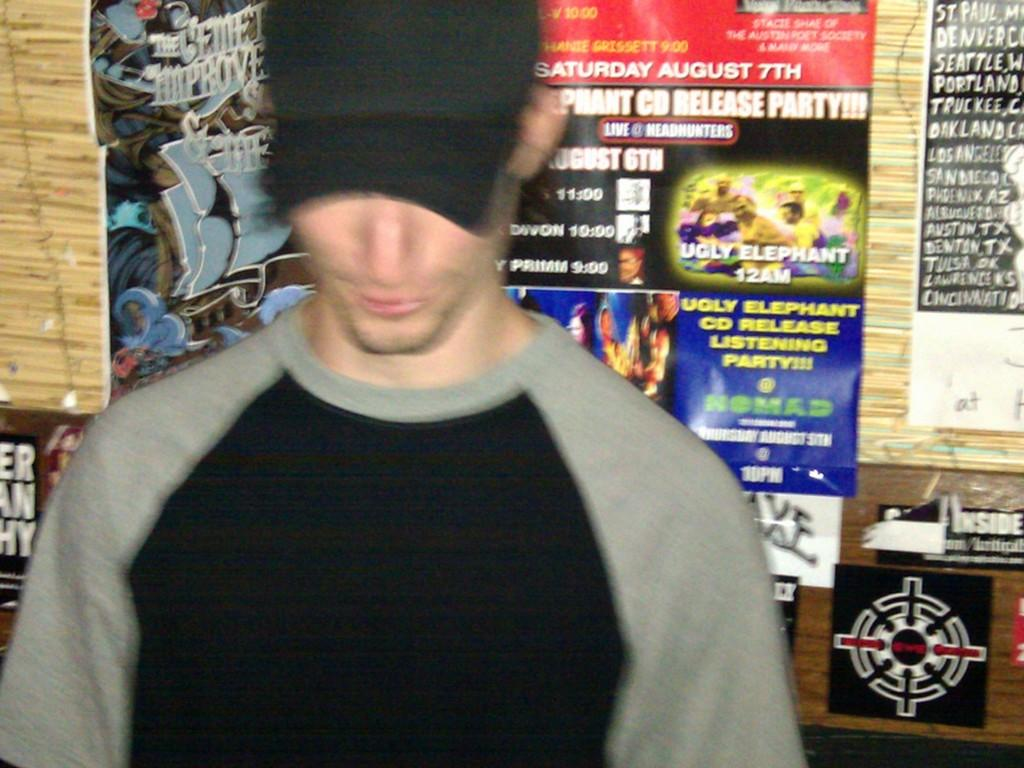Who or what is the main subject in the image? There is a person in the image. Can you describe the person's attire? The person is wearing a cap. What can be seen in the background of the image? There are posters in the background of the image. How are the posters positioned in the image? The posters are attached to a wall. What type of pear is being washed in the sink in the image? There is no sink or pear present in the image. 